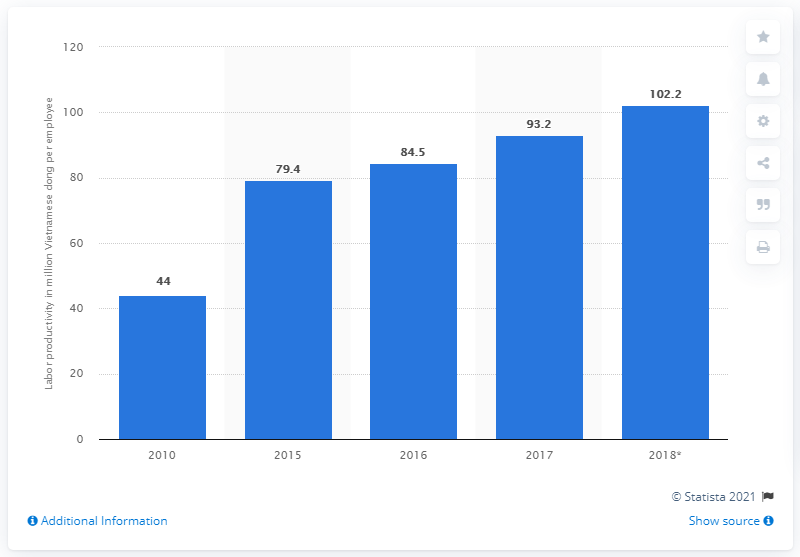Give some essential details in this illustration. In 2018, the GDP contribution per employed person in Vietnam was 102.2. 